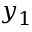<formula> <loc_0><loc_0><loc_500><loc_500>y _ { 1 }</formula> 